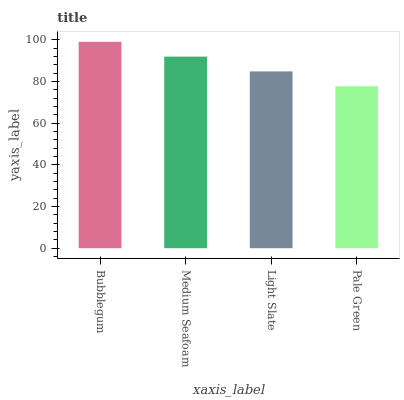Is Pale Green the minimum?
Answer yes or no. Yes. Is Bubblegum the maximum?
Answer yes or no. Yes. Is Medium Seafoam the minimum?
Answer yes or no. No. Is Medium Seafoam the maximum?
Answer yes or no. No. Is Bubblegum greater than Medium Seafoam?
Answer yes or no. Yes. Is Medium Seafoam less than Bubblegum?
Answer yes or no. Yes. Is Medium Seafoam greater than Bubblegum?
Answer yes or no. No. Is Bubblegum less than Medium Seafoam?
Answer yes or no. No. Is Medium Seafoam the high median?
Answer yes or no. Yes. Is Light Slate the low median?
Answer yes or no. Yes. Is Bubblegum the high median?
Answer yes or no. No. Is Bubblegum the low median?
Answer yes or no. No. 